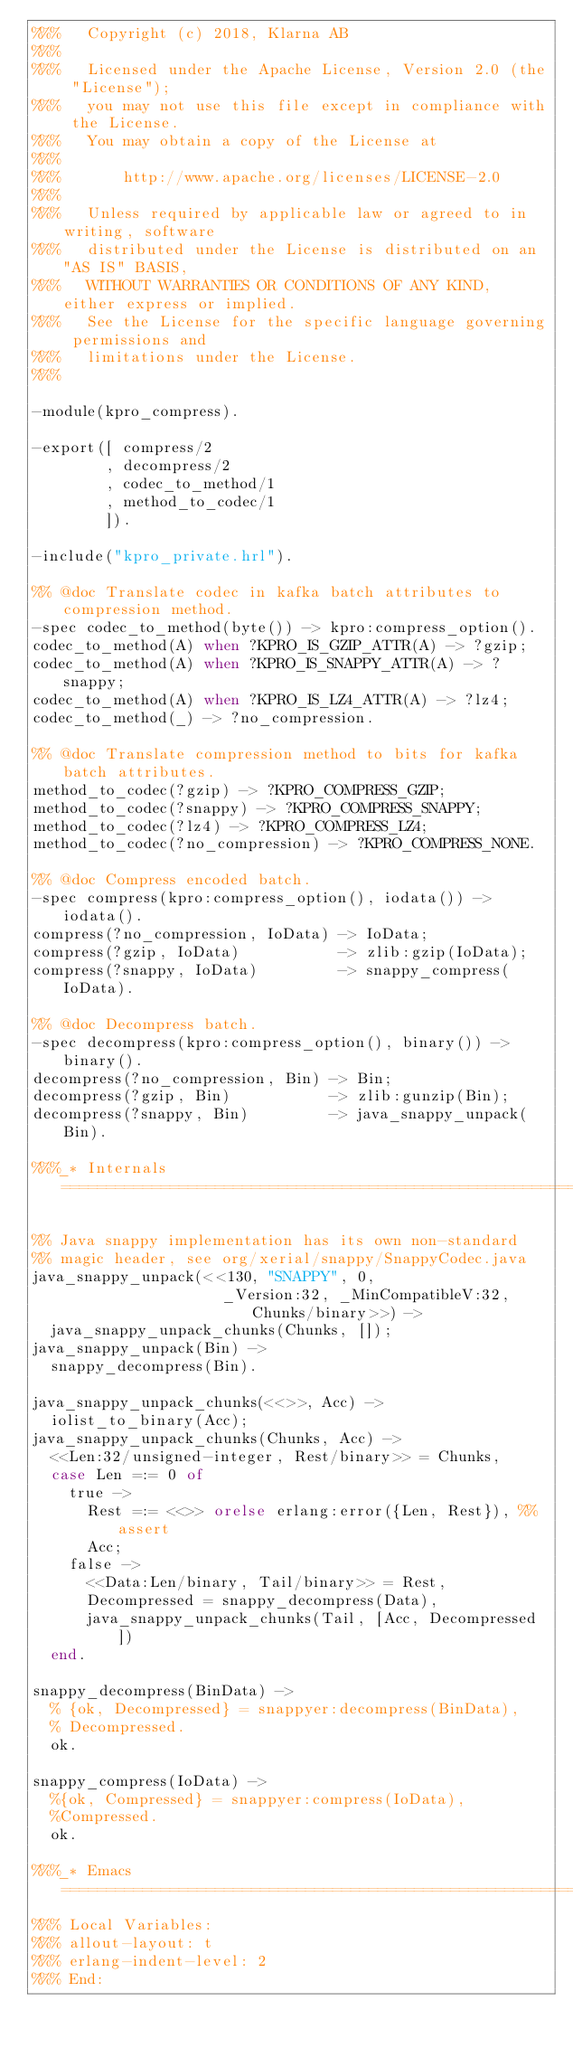Convert code to text. <code><loc_0><loc_0><loc_500><loc_500><_Erlang_>%%%   Copyright (c) 2018, Klarna AB
%%%
%%%   Licensed under the Apache License, Version 2.0 (the "License");
%%%   you may not use this file except in compliance with the License.
%%%   You may obtain a copy of the License at
%%%
%%%       http://www.apache.org/licenses/LICENSE-2.0
%%%
%%%   Unless required by applicable law or agreed to in writing, software
%%%   distributed under the License is distributed on an "AS IS" BASIS,
%%%   WITHOUT WARRANTIES OR CONDITIONS OF ANY KIND, either express or implied.
%%%   See the License for the specific language governing permissions and
%%%   limitations under the License.
%%%

-module(kpro_compress).

-export([ compress/2
        , decompress/2
        , codec_to_method/1
        , method_to_codec/1
        ]).

-include("kpro_private.hrl").

%% @doc Translate codec in kafka batch attributes to compression method.
-spec codec_to_method(byte()) -> kpro:compress_option().
codec_to_method(A) when ?KPRO_IS_GZIP_ATTR(A) -> ?gzip;
codec_to_method(A) when ?KPRO_IS_SNAPPY_ATTR(A) -> ?snappy;
codec_to_method(A) when ?KPRO_IS_LZ4_ATTR(A) -> ?lz4;
codec_to_method(_) -> ?no_compression.

%% @doc Translate compression method to bits for kafka batch attributes.
method_to_codec(?gzip) -> ?KPRO_COMPRESS_GZIP;
method_to_codec(?snappy) -> ?KPRO_COMPRESS_SNAPPY;
method_to_codec(?lz4) -> ?KPRO_COMPRESS_LZ4;
method_to_codec(?no_compression) -> ?KPRO_COMPRESS_NONE.

%% @doc Compress encoded batch.
-spec compress(kpro:compress_option(), iodata()) -> iodata().
compress(?no_compression, IoData) -> IoData;
compress(?gzip, IoData)           -> zlib:gzip(IoData);
compress(?snappy, IoData)         -> snappy_compress(IoData).

%% @doc Decompress batch.
-spec decompress(kpro:compress_option(), binary()) -> binary().
decompress(?no_compression, Bin) -> Bin;
decompress(?gzip, Bin)           -> zlib:gunzip(Bin);
decompress(?snappy, Bin)         -> java_snappy_unpack(Bin).

%%%_* Internals ================================================================

%% Java snappy implementation has its own non-standard
%% magic header, see org/xerial/snappy/SnappyCodec.java
java_snappy_unpack(<<130, "SNAPPY", 0,
                     _Version:32, _MinCompatibleV:32, Chunks/binary>>) ->
  java_snappy_unpack_chunks(Chunks, []);
java_snappy_unpack(Bin) ->
  snappy_decompress(Bin).

java_snappy_unpack_chunks(<<>>, Acc) ->
  iolist_to_binary(Acc);
java_snappy_unpack_chunks(Chunks, Acc) ->
  <<Len:32/unsigned-integer, Rest/binary>> = Chunks,
  case Len =:= 0 of
    true ->
      Rest =:= <<>> orelse erlang:error({Len, Rest}), %% assert
      Acc;
    false ->
      <<Data:Len/binary, Tail/binary>> = Rest,
      Decompressed = snappy_decompress(Data),
      java_snappy_unpack_chunks(Tail, [Acc, Decompressed])
  end.

snappy_decompress(BinData) ->
  % {ok, Decompressed} = snappyer:decompress(BinData),
  % Decompressed.
  ok.

snappy_compress(IoData) ->
  %{ok, Compressed} = snappyer:compress(IoData),
  %Compressed.
  ok.
  
%%%_* Emacs ====================================================================
%%% Local Variables:
%%% allout-layout: t
%%% erlang-indent-level: 2
%%% End:
</code> 